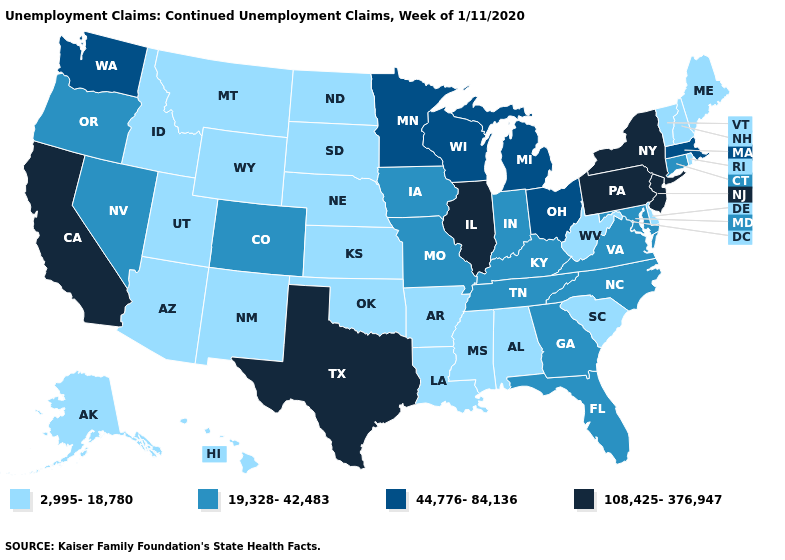What is the value of Colorado?
Write a very short answer. 19,328-42,483. What is the highest value in states that border Nevada?
Short answer required. 108,425-376,947. What is the value of Massachusetts?
Be succinct. 44,776-84,136. What is the value of North Dakota?
Short answer required. 2,995-18,780. Does the first symbol in the legend represent the smallest category?
Quick response, please. Yes. Which states have the lowest value in the USA?
Be succinct. Alabama, Alaska, Arizona, Arkansas, Delaware, Hawaii, Idaho, Kansas, Louisiana, Maine, Mississippi, Montana, Nebraska, New Hampshire, New Mexico, North Dakota, Oklahoma, Rhode Island, South Carolina, South Dakota, Utah, Vermont, West Virginia, Wyoming. What is the value of Vermont?
Give a very brief answer. 2,995-18,780. Among the states that border Wyoming , does Colorado have the lowest value?
Quick response, please. No. Name the states that have a value in the range 44,776-84,136?
Concise answer only. Massachusetts, Michigan, Minnesota, Ohio, Washington, Wisconsin. What is the value of South Dakota?
Answer briefly. 2,995-18,780. Name the states that have a value in the range 2,995-18,780?
Concise answer only. Alabama, Alaska, Arizona, Arkansas, Delaware, Hawaii, Idaho, Kansas, Louisiana, Maine, Mississippi, Montana, Nebraska, New Hampshire, New Mexico, North Dakota, Oklahoma, Rhode Island, South Carolina, South Dakota, Utah, Vermont, West Virginia, Wyoming. Does New Mexico have the same value as Florida?
Keep it brief. No. Name the states that have a value in the range 19,328-42,483?
Answer briefly. Colorado, Connecticut, Florida, Georgia, Indiana, Iowa, Kentucky, Maryland, Missouri, Nevada, North Carolina, Oregon, Tennessee, Virginia. What is the value of Oregon?
Concise answer only. 19,328-42,483. Name the states that have a value in the range 2,995-18,780?
Concise answer only. Alabama, Alaska, Arizona, Arkansas, Delaware, Hawaii, Idaho, Kansas, Louisiana, Maine, Mississippi, Montana, Nebraska, New Hampshire, New Mexico, North Dakota, Oklahoma, Rhode Island, South Carolina, South Dakota, Utah, Vermont, West Virginia, Wyoming. 